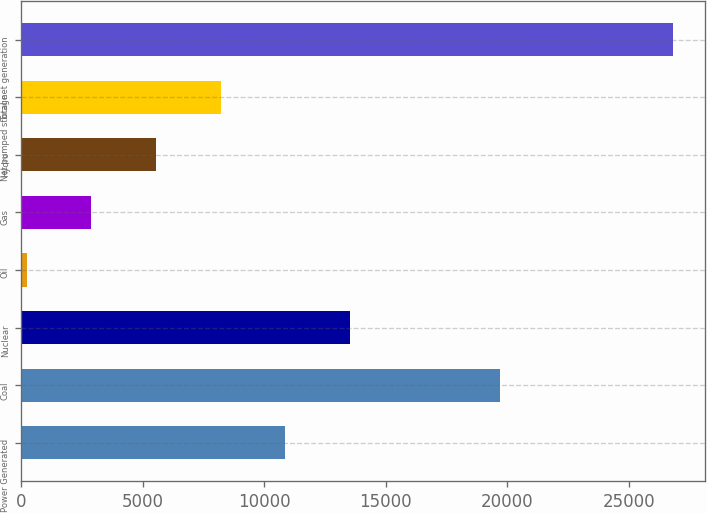<chart> <loc_0><loc_0><loc_500><loc_500><bar_chart><fcel>Power Generated<fcel>Coal<fcel>Nuclear<fcel>Oil<fcel>Gas<fcel>Hydro<fcel>Net pumped storage<fcel>Total net generation<nl><fcel>10854.6<fcel>19711<fcel>13512<fcel>225<fcel>2882.4<fcel>5539.8<fcel>8197.2<fcel>26799<nl></chart> 